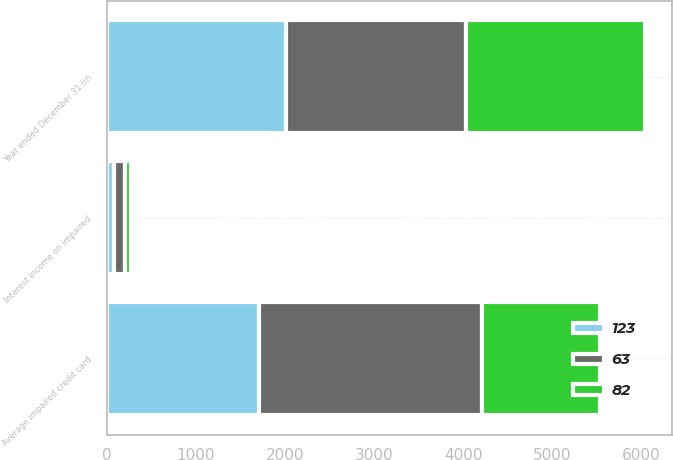Convert chart. <chart><loc_0><loc_0><loc_500><loc_500><stacked_bar_chart><ecel><fcel>Year ended December 31 (in<fcel>Average impaired credit card<fcel>Interest income on impaired<nl><fcel>82<fcel>2016<fcel>1325<fcel>63<nl><fcel>123<fcel>2015<fcel>1710<fcel>82<nl><fcel>63<fcel>2014<fcel>2503<fcel>123<nl></chart> 